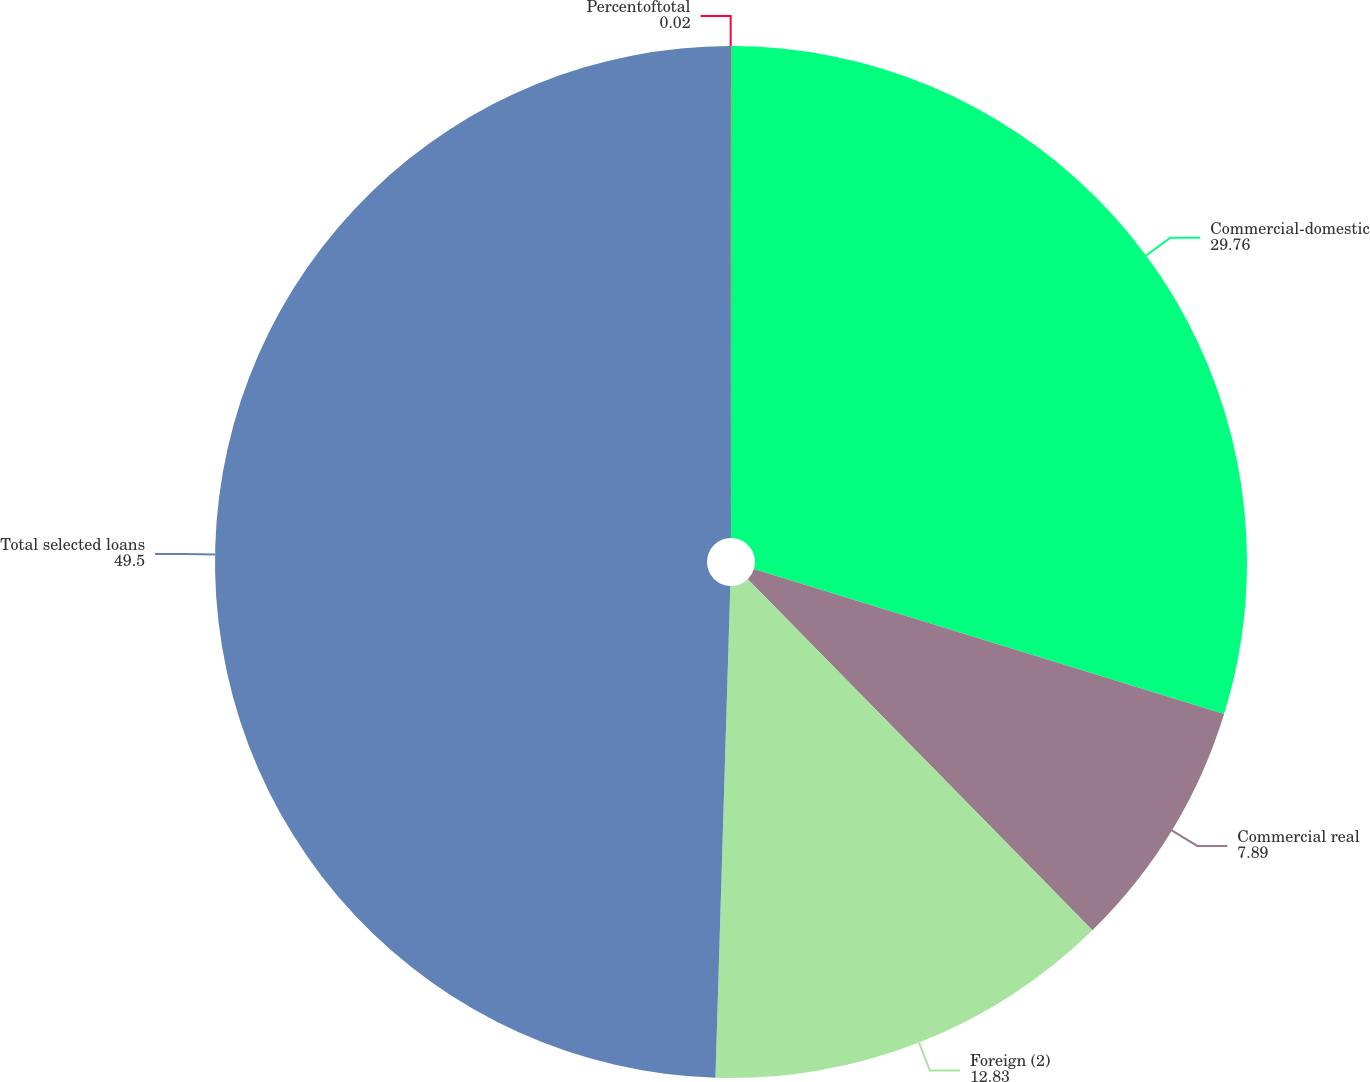Convert chart. <chart><loc_0><loc_0><loc_500><loc_500><pie_chart><fcel>Commercial-domestic<fcel>Commercial real<fcel>Foreign (2)<fcel>Total selected loans<fcel>Percentoftotal<nl><fcel>29.76%<fcel>7.89%<fcel>12.83%<fcel>49.5%<fcel>0.02%<nl></chart> 